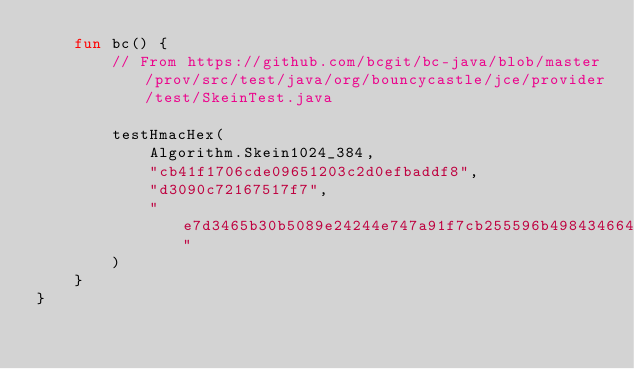<code> <loc_0><loc_0><loc_500><loc_500><_Kotlin_>    fun bc() {
        // From https://github.com/bcgit/bc-java/blob/master/prov/src/test/java/org/bouncycastle/jce/provider/test/SkeinTest.java

        testHmacHex(
            Algorithm.Skein1024_384,
            "cb41f1706cde09651203c2d0efbaddf8",
            "d3090c72167517f7",
            "e7d3465b30b5089e24244e747a91f7cb255596b49843466497c07e120c5c2232f51151b185a1e8a5610f041a85cc59ee"
        )
    }
}
</code> 